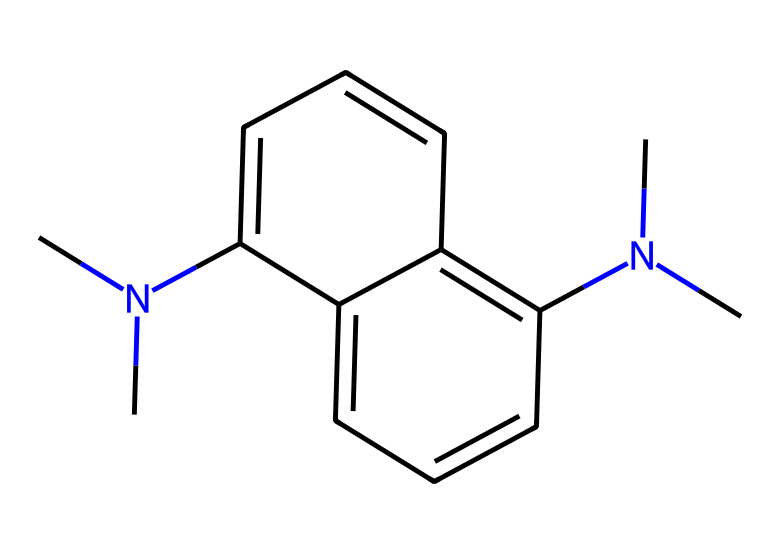What is the total number of nitrogen atoms in this compound? In the provided SMILES representation, the nitrogen (N) atoms can be identified clearly. Here, there are two distinct nitrogen atoms present in the structure.
Answer: 2 How many aromatic rings are present in the compound? Analyzing the structure, we observe that there are two interconnected aromatic rings in the compound, indicated by the presence of alternating double bonds in the cyclic structures.
Answer: 2 What type of bonding is primarily responsible for the stability of this proton sponge? The compound features significant delocalized pi-electron systems across the aromatic rings, which are indicative of resonance stabilization. This effective overlap helps maintain structural stability.
Answer: resonance What is the role of the branched amine groups in this molecule? The branched amine groups contribute to the basicity and proton affinity of the compound, enhancing its potential as a proton sponge by forming stable protonated species.
Answer: basicity What key property of this compound enhances its effectiveness in aerospace adhesives? The presence of strong hydrogen bonding capabilities, due to the nitrogen atoms and branch structures, significantly aids in the adhesion properties necessary for aerospace applications.
Answer: hydrogen bonding How does the structural composition influence its potential use as a superbase? The steric hindrance provided by branched amines offers improved solvation and interactions with acids, allowing the compound to function effectively as a superbase in various chemical reactions.
Answer: steric hindrance 